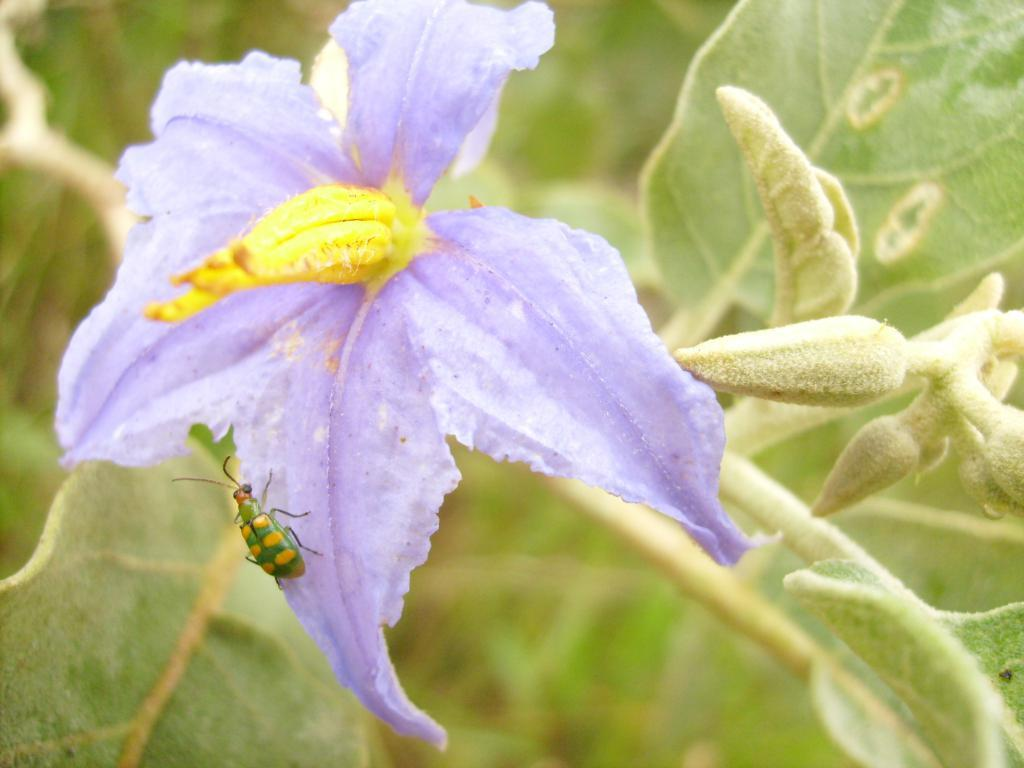What is the main subject of the image? There is a flower in the image. Can you describe the color of the flower? The flower is purple. What else can be seen on the flower in the image? There is an insect on the flower. What can be seen in the background of the image? There are leaves and plants in the background of the image. What type of scarecrow is standing in the middle of the garden in the image? There is no scarecrow or garden present in the image; it features a purple flower with an insect on it and a background of leaves and plants. What month is it in the image? The image does not provide any information about the month or time of year. 